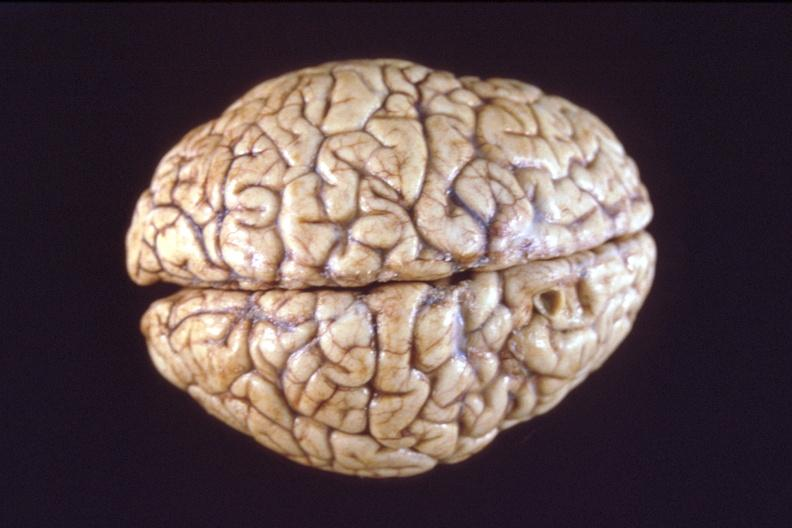s nervous present?
Answer the question using a single word or phrase. Yes 